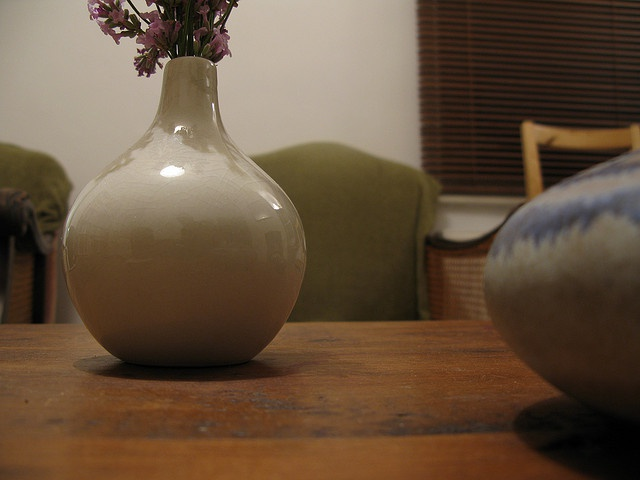Describe the objects in this image and their specific colors. I can see dining table in gray, maroon, black, and brown tones, vase in gray, maroon, black, and tan tones, vase in gray and black tones, chair in gray, black, and olive tones, and chair in gray, black, and olive tones in this image. 